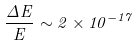<formula> <loc_0><loc_0><loc_500><loc_500>\frac { \Delta E } { E } \sim 2 \times 1 0 ^ { - 1 7 }</formula> 